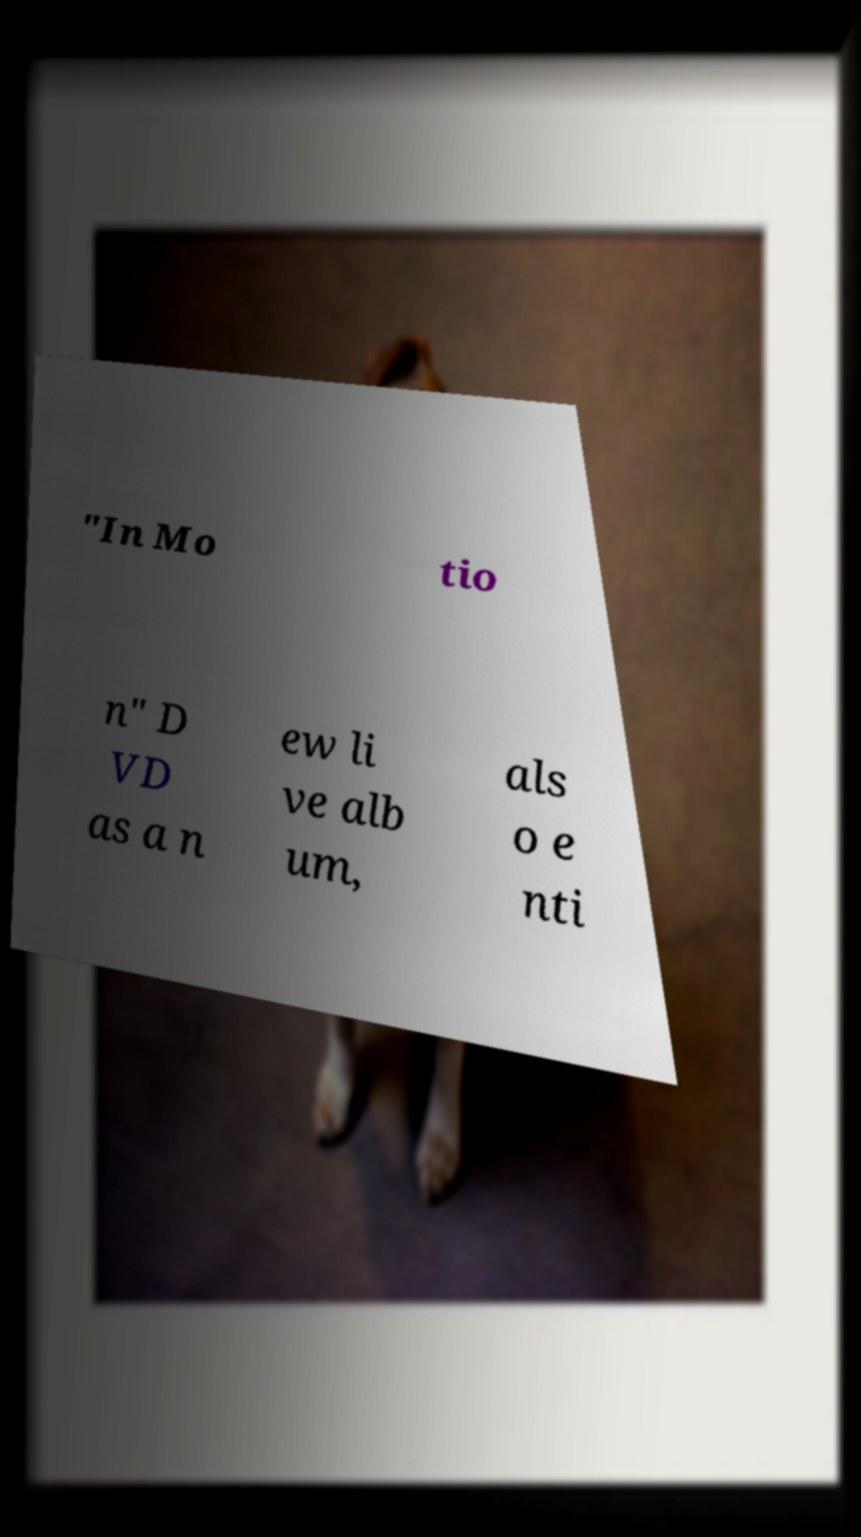What messages or text are displayed in this image? I need them in a readable, typed format. "In Mo tio n" D VD as a n ew li ve alb um, als o e nti 